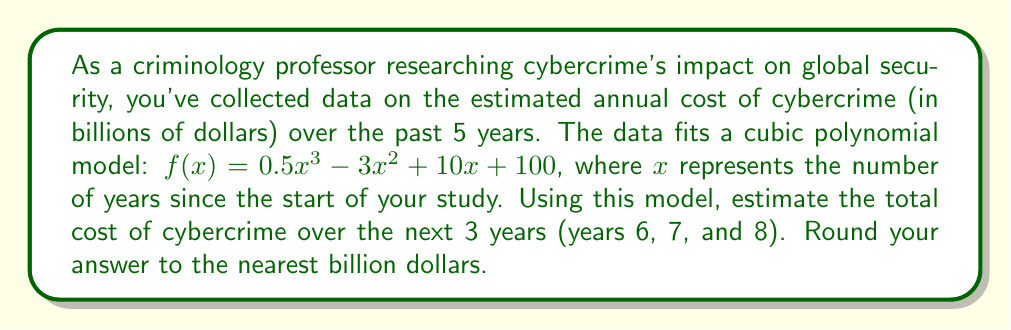Could you help me with this problem? To solve this problem, we need to follow these steps:

1) The polynomial model is given as:
   $f(x) = 0.5x^3 - 3x^2 + 10x + 100$

2) We need to calculate the cost for years 6, 7, and 8:

   For x = 6:
   $f(6) = 0.5(6^3) - 3(6^2) + 10(6) + 100$
   $= 0.5(216) - 3(36) + 60 + 100$
   $= 108 - 108 + 60 + 100$
   $= 160$ billion dollars

   For x = 7:
   $f(7) = 0.5(7^3) - 3(7^2) + 10(7) + 100$
   $= 0.5(343) - 3(49) + 70 + 100$
   $= 171.5 - 147 + 70 + 100$
   $= 194.5$ billion dollars

   For x = 8:
   $f(8) = 0.5(8^3) - 3(8^2) + 10(8) + 100$
   $= 0.5(512) - 3(64) + 80 + 100$
   $= 256 - 192 + 80 + 100$
   $= 244$ billion dollars

3) Sum up the costs for these three years:
   $160 + 194.5 + 244 = 598.5$ billion dollars

4) Rounding to the nearest billion:
   $598.5$ billion rounds to $599$ billion
Answer: $599 billion 